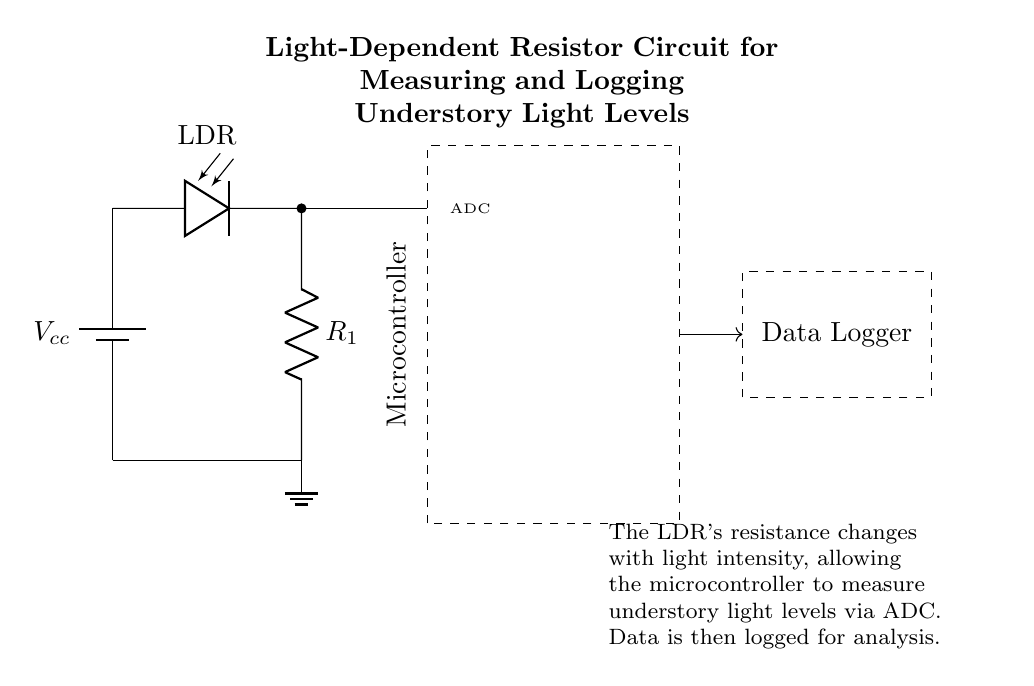What component is used to measure light levels? The light-dependent resistor (LDR) is the component that senses the intensity of light and changes its resistance accordingly.
Answer: LDR What does the dashed rectangle represent? The dashed rectangle labeled as "Microcontroller" indicates the envelope of the microcontroller, which processes the input from the LDR and manages the data logging.
Answer: Microcontroller What is the role of the resistor in the circuit? The resistor (R1) is used in conjunction with the LDR to create a voltage divider, allowing the microcontroller to read varying voltages based on light intensity.
Answer: Voltage divider How does the microcontroller get the data from the LDR? The microcontroller receives the analog voltage signal from the LDR through the ADC (Analog-to-Digital Converter), which converts this analog signal into a digital form for processing.
Answer: ADC What is the purpose of the data logger connected to the microcontroller? The data logger is designed to record the digitized light intensity values provided by the microcontroller for further analysis of the understory light levels over time.
Answer: Data Logger What type of circuit is this? This circuit is a low power measurement circuit specifically designed for environmental monitoring to measure light levels in an understory.
Answer: Measurement circuit 